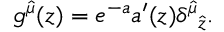<formula> <loc_0><loc_0><loc_500><loc_500>g ^ { \hat { \mu } } ( z ) = e ^ { - a } a ^ { \prime } ( z ) { \delta ^ { \hat { \mu } } } _ { \hat { z } } .</formula> 